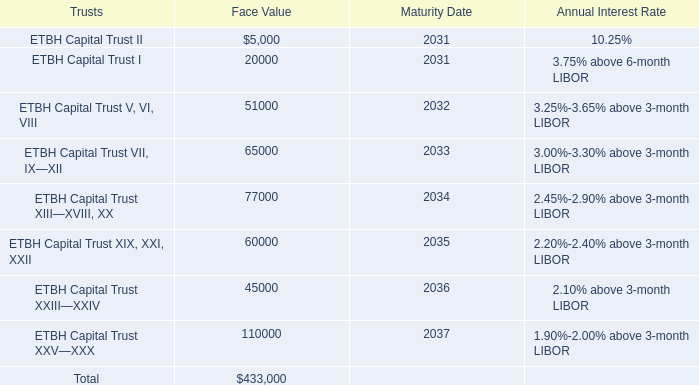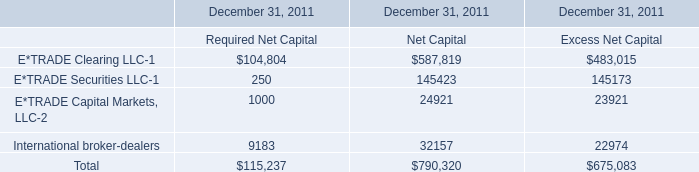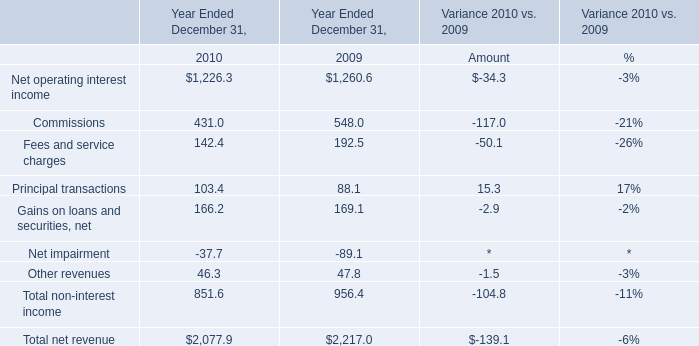What's the average of ETBH Capital Trust XIX, XXI, XXII of Face Value, and E*TRADE Securities LLC of December 31, 2011 Net Capital ? 
Computations: ((60000.0 + 145423.0) / 2)
Answer: 102711.5. 